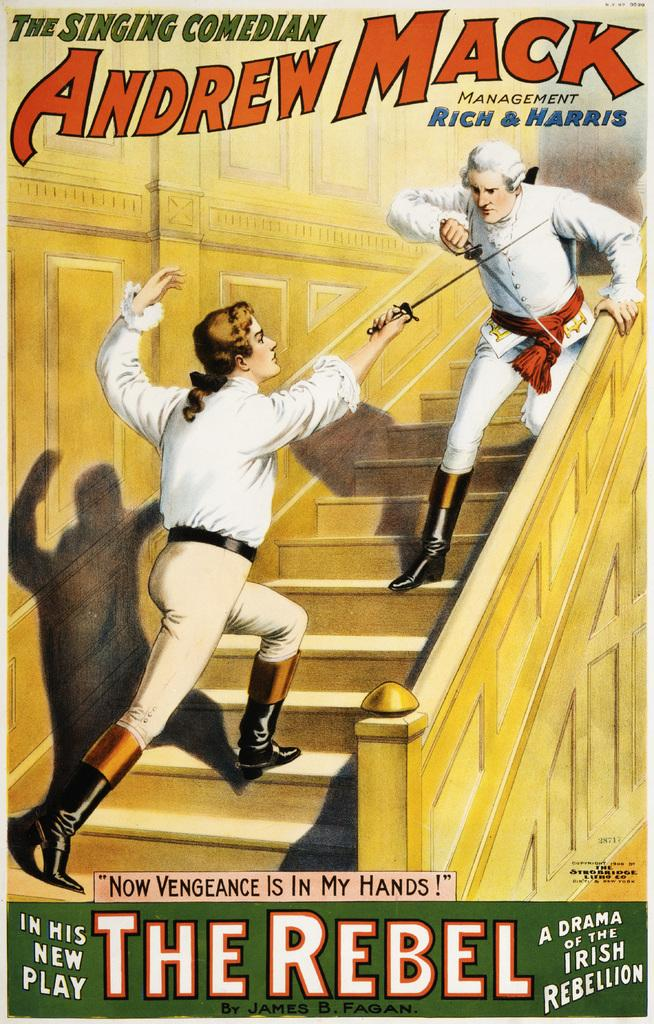<image>
Provide a brief description of the given image. An advertisement for an old play THE SINGING COMEDIAN ANDREW MACK MANAGEMENT RICH & HARRIS, with THE REBEL at the bottom of the ad. 